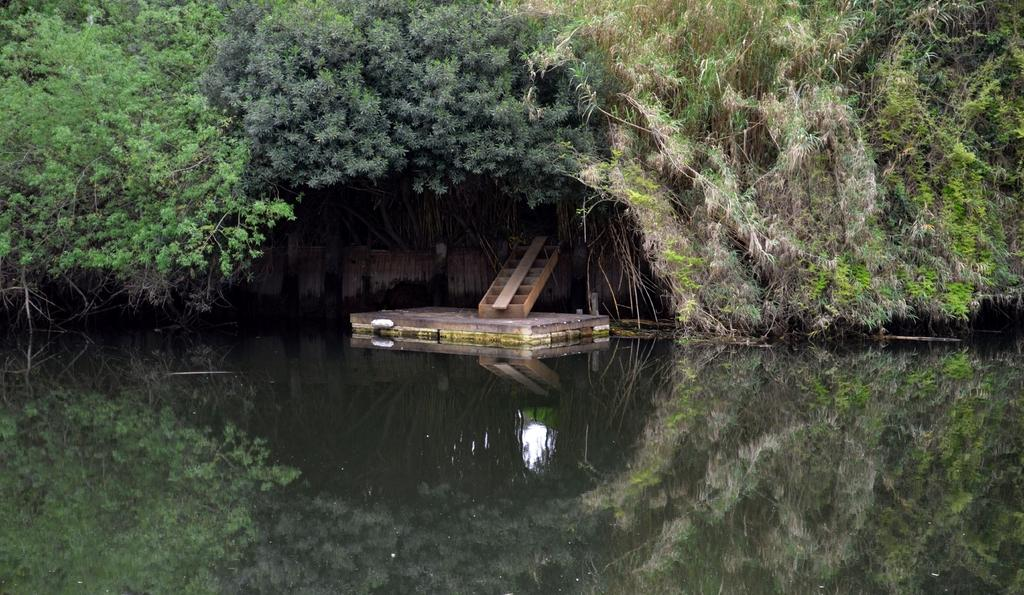What is present at the bottom of the image? There is water at the bottom side of the image. What is floating on the water? There is a wooden log on the water. What can be seen at the top of the image? There are trees at the top side of the image. How many apples are hanging from the trees in the image? There is no mention of apples in the image; it only features water, a wooden log, and trees. Are there any horses visible in the image? There is no mention of horses in the image; it only features water, a wooden log, and trees. 